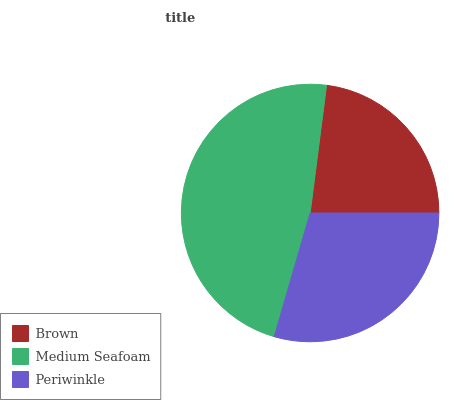Is Brown the minimum?
Answer yes or no. Yes. Is Medium Seafoam the maximum?
Answer yes or no. Yes. Is Periwinkle the minimum?
Answer yes or no. No. Is Periwinkle the maximum?
Answer yes or no. No. Is Medium Seafoam greater than Periwinkle?
Answer yes or no. Yes. Is Periwinkle less than Medium Seafoam?
Answer yes or no. Yes. Is Periwinkle greater than Medium Seafoam?
Answer yes or no. No. Is Medium Seafoam less than Periwinkle?
Answer yes or no. No. Is Periwinkle the high median?
Answer yes or no. Yes. Is Periwinkle the low median?
Answer yes or no. Yes. Is Medium Seafoam the high median?
Answer yes or no. No. Is Brown the low median?
Answer yes or no. No. 